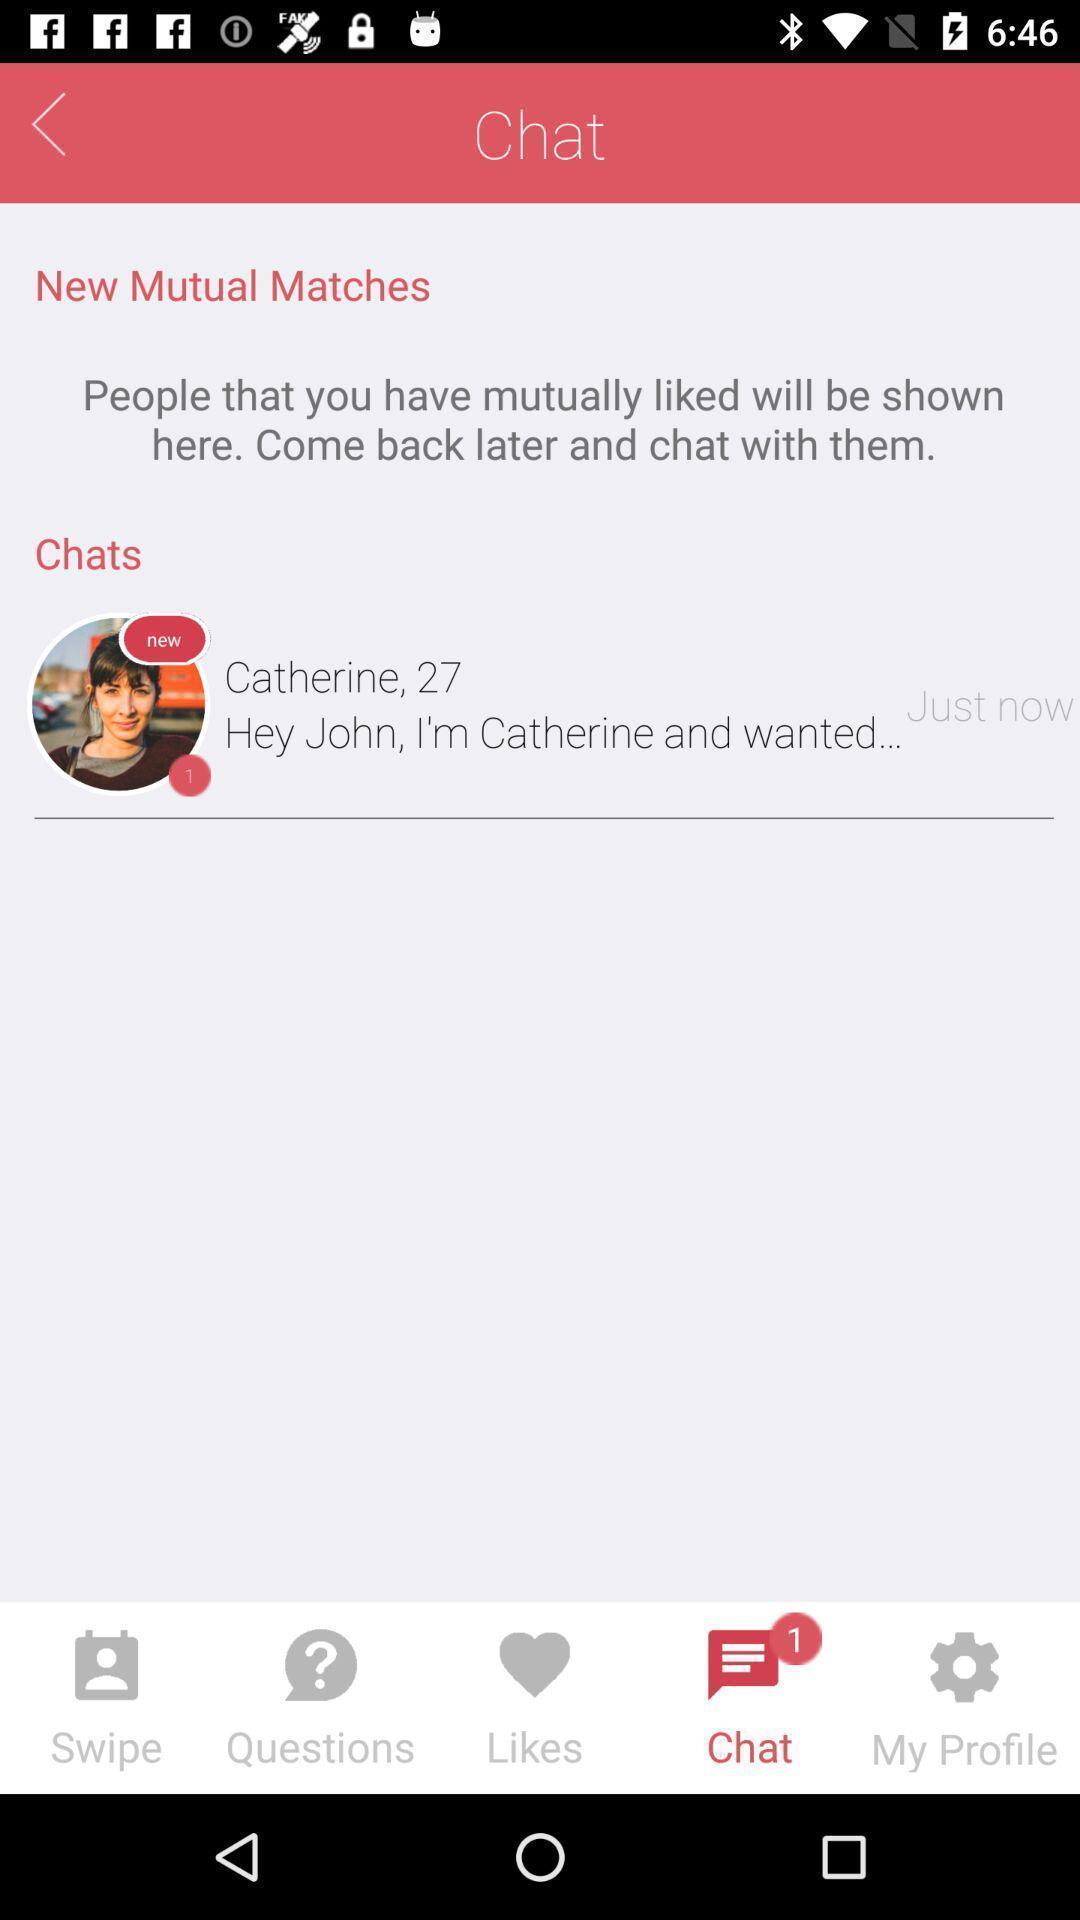Tell me what you see in this picture. Page shows a social networking website. 